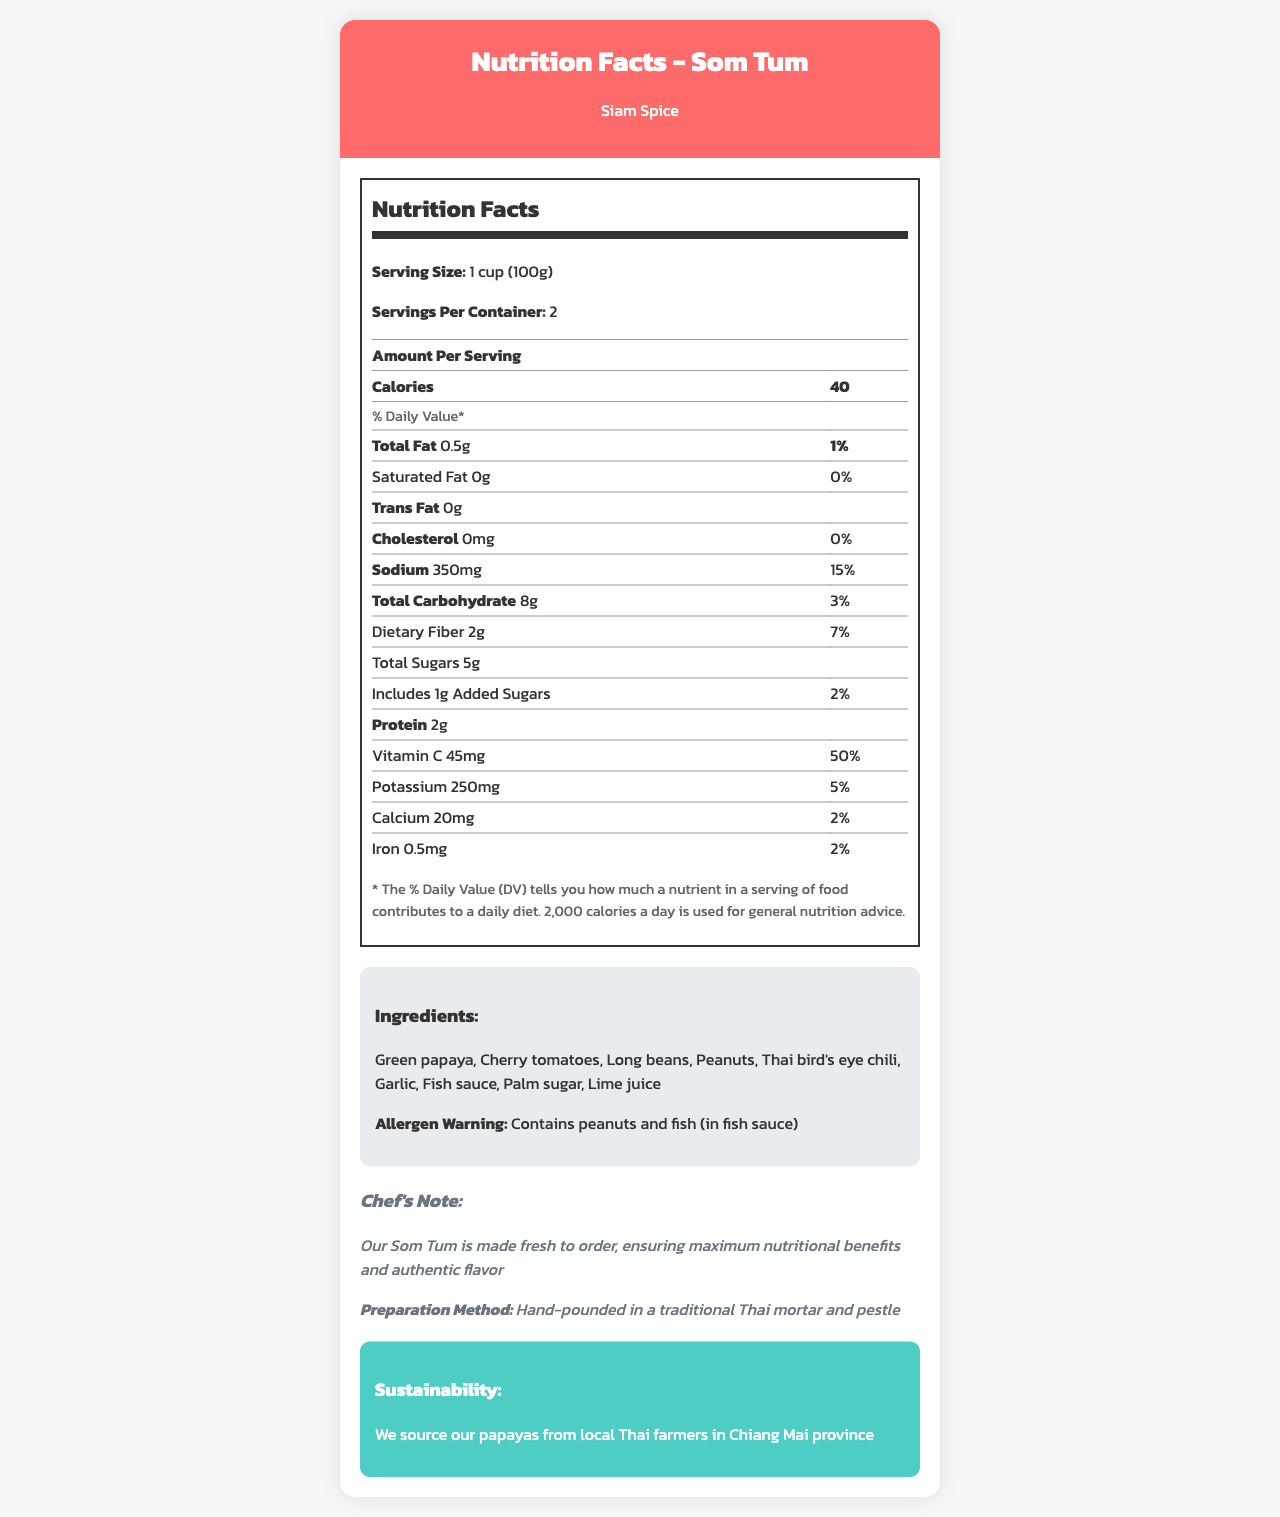what is the serving size for Som Tum? The serving size is explicitly mentioned as "1 cup (100g)."
Answer: 1 cup (100g) how many servings are there per container? The document states that there are 2 servings per container.
Answer: 2 how much Vitamin C is in one serving of Som Tum? The amount of Vitamin C per serving is listed as 45mg.
Answer: 45mg how much potassium is there per serving? The document shows 250mg of potassium per serving.
Answer: 250mg what ingredients are used in Som Tum? The ingredients are listed under the ingredients section.
Answer: Green papaya, Cherry tomatoes, Long beans, Peanuts, Thai bird's eye chili, Garlic, Fish sauce, Palm sugar, Lime juice which restaurant serves this Som Tum? The restaurant name is provided at the top of the document saying "Nutrition Facts - Som Tum" with "Siam Spice."
Answer: Siam Spice what is the total amount of fat per serving? A. 0.5g B. 1g C. 1.5g The "total fat" listed per serving is 0.5g.
Answer: A what is the percentage of daily value for dietary fiber? A. 3% B. 5% C. 7% D. 10% The percentage of daily value for dietary fiber is 7% as stated in the document.
Answer: C is there any trans fat in Som Tum? The document lists trans fat as 0g, meaning there is none in the dish.
Answer: No how is Som Tum prepared at Siam Spice? The preparation method mentioned is hand-pounded in a traditional Thai mortar and pestle.
Answer: Hand-pounded in a traditional Thai mortar and pestle what is the calorie count per serving? The number of calories per serving is clearly noted as 40.
Answer: 40 calories does this Som Tum contain any allergens? The allergen warning indicates that it contains peanuts and fish (in fish sauce).
Answer: Yes where are the papayas used in Som Tum sourced from? The document mentions that the papayas are sourced from local Thai farmers in Chiang Mai province.
Answer: Local Thai farmers in Chiang Mai province how much cholesterol is in one serving? The cholesterol amount is stated as 0mg per serving in the document.
Answer: 0mg what is the total carbohydrate content per serving? The total carbohydrate content is 8g per serving.
Answer: 8g how many grams of protein are in one serving of Som Tum? The amount of protein per serving is listed as 2g.
Answer: 2g describe the main idea of the nutrition facts label for Som Tum The document is focused on presenting a comprehensive nutritional summary for Som Tum, including serving size, nutrient content, ingredients, allergens, and sustainability aspects.
Answer: The document provides detailed nutritional information for Som Tum, including calories, fat, vitamins, and other nutrients per serving. It also lists ingredients, allergens, preparation methods, and sustainability information related to the dish served at Siam Spice. who is the head chef at Siam Spice? The document does not provide the name of the head chef or any personal details about the kitchen staff.
Answer: Not enough information 